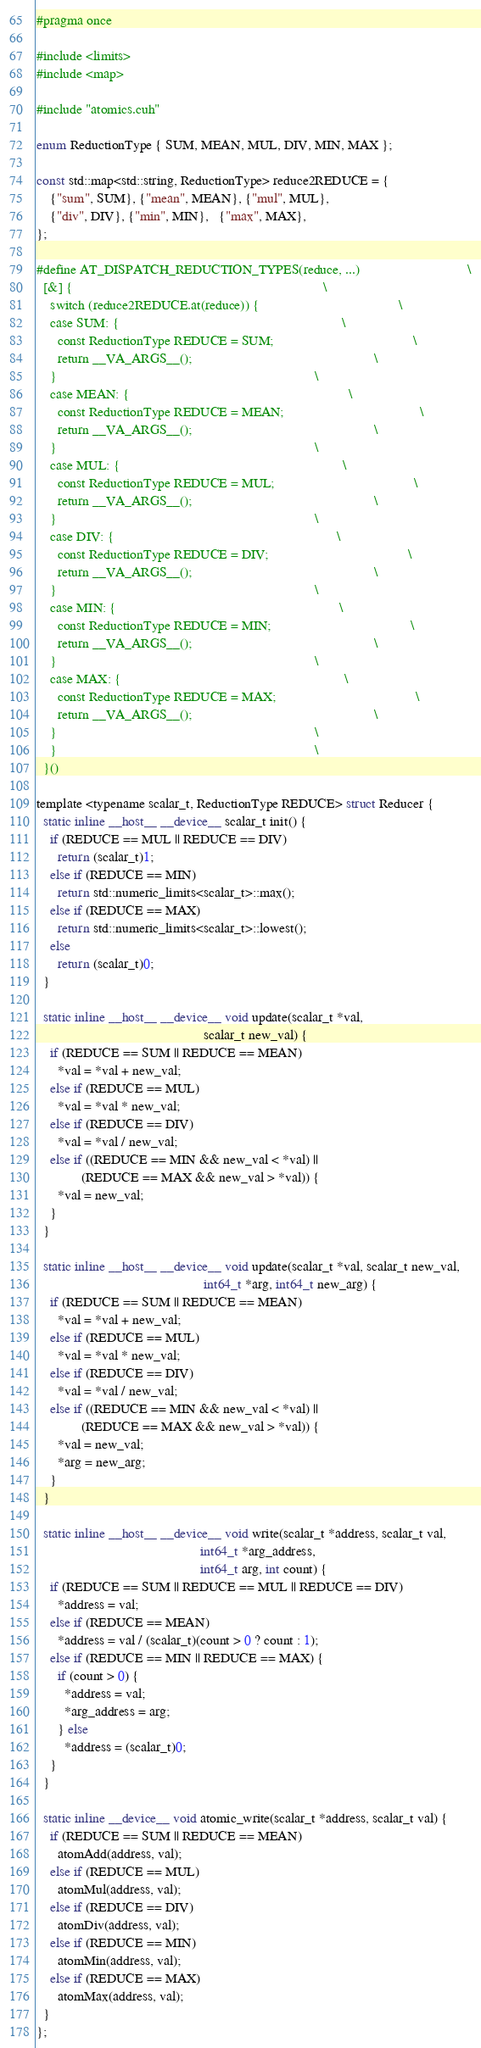Convert code to text. <code><loc_0><loc_0><loc_500><loc_500><_Cuda_>#pragma once

#include <limits>
#include <map>

#include "atomics.cuh"

enum ReductionType { SUM, MEAN, MUL, DIV, MIN, MAX };

const std::map<std::string, ReductionType> reduce2REDUCE = {
    {"sum", SUM}, {"mean", MEAN}, {"mul", MUL},
    {"div", DIV}, {"min", MIN},   {"max", MAX},
};

#define AT_DISPATCH_REDUCTION_TYPES(reduce, ...)                               \
  [&] {                                                                        \
    switch (reduce2REDUCE.at(reduce)) {                                        \
    case SUM: {                                                                \
      const ReductionType REDUCE = SUM;                                        \
      return __VA_ARGS__();                                                    \
    }                                                                          \
    case MEAN: {                                                               \
      const ReductionType REDUCE = MEAN;                                       \
      return __VA_ARGS__();                                                    \
    }                                                                          \
    case MUL: {                                                                \
      const ReductionType REDUCE = MUL;                                        \
      return __VA_ARGS__();                                                    \
    }                                                                          \
    case DIV: {                                                                \
      const ReductionType REDUCE = DIV;                                        \
      return __VA_ARGS__();                                                    \
    }                                                                          \
    case MIN: {                                                                \
      const ReductionType REDUCE = MIN;                                        \
      return __VA_ARGS__();                                                    \
    }                                                                          \
    case MAX: {                                                                \
      const ReductionType REDUCE = MAX;                                        \
      return __VA_ARGS__();                                                    \
    }                                                                          \
    }                                                                          \
  }()

template <typename scalar_t, ReductionType REDUCE> struct Reducer {
  static inline __host__ __device__ scalar_t init() {
    if (REDUCE == MUL || REDUCE == DIV)
      return (scalar_t)1;
    else if (REDUCE == MIN)
      return std::numeric_limits<scalar_t>::max();
    else if (REDUCE == MAX)
      return std::numeric_limits<scalar_t>::lowest();
    else
      return (scalar_t)0;
  }

  static inline __host__ __device__ void update(scalar_t *val,
                                                scalar_t new_val) {
    if (REDUCE == SUM || REDUCE == MEAN)
      *val = *val + new_val;
    else if (REDUCE == MUL)
      *val = *val * new_val;
    else if (REDUCE == DIV)
      *val = *val / new_val;
    else if ((REDUCE == MIN && new_val < *val) ||
             (REDUCE == MAX && new_val > *val)) {
      *val = new_val;
    }
  }

  static inline __host__ __device__ void update(scalar_t *val, scalar_t new_val,
                                                int64_t *arg, int64_t new_arg) {
    if (REDUCE == SUM || REDUCE == MEAN)
      *val = *val + new_val;
    else if (REDUCE == MUL)
      *val = *val * new_val;
    else if (REDUCE == DIV)
      *val = *val / new_val;
    else if ((REDUCE == MIN && new_val < *val) ||
             (REDUCE == MAX && new_val > *val)) {
      *val = new_val;
      *arg = new_arg;
    }
  }

  static inline __host__ __device__ void write(scalar_t *address, scalar_t val,
                                               int64_t *arg_address,
                                               int64_t arg, int count) {
    if (REDUCE == SUM || REDUCE == MUL || REDUCE == DIV)
      *address = val;
    else if (REDUCE == MEAN)
      *address = val / (scalar_t)(count > 0 ? count : 1);
    else if (REDUCE == MIN || REDUCE == MAX) {
      if (count > 0) {
        *address = val;
        *arg_address = arg;
      } else
        *address = (scalar_t)0;
    }
  }

  static inline __device__ void atomic_write(scalar_t *address, scalar_t val) {
    if (REDUCE == SUM || REDUCE == MEAN)
      atomAdd(address, val);
    else if (REDUCE == MUL)
      atomMul(address, val);
    else if (REDUCE == DIV)
      atomDiv(address, val);
    else if (REDUCE == MIN)
      atomMin(address, val);
    else if (REDUCE == MAX)
      atomMax(address, val);
  }
};
</code> 